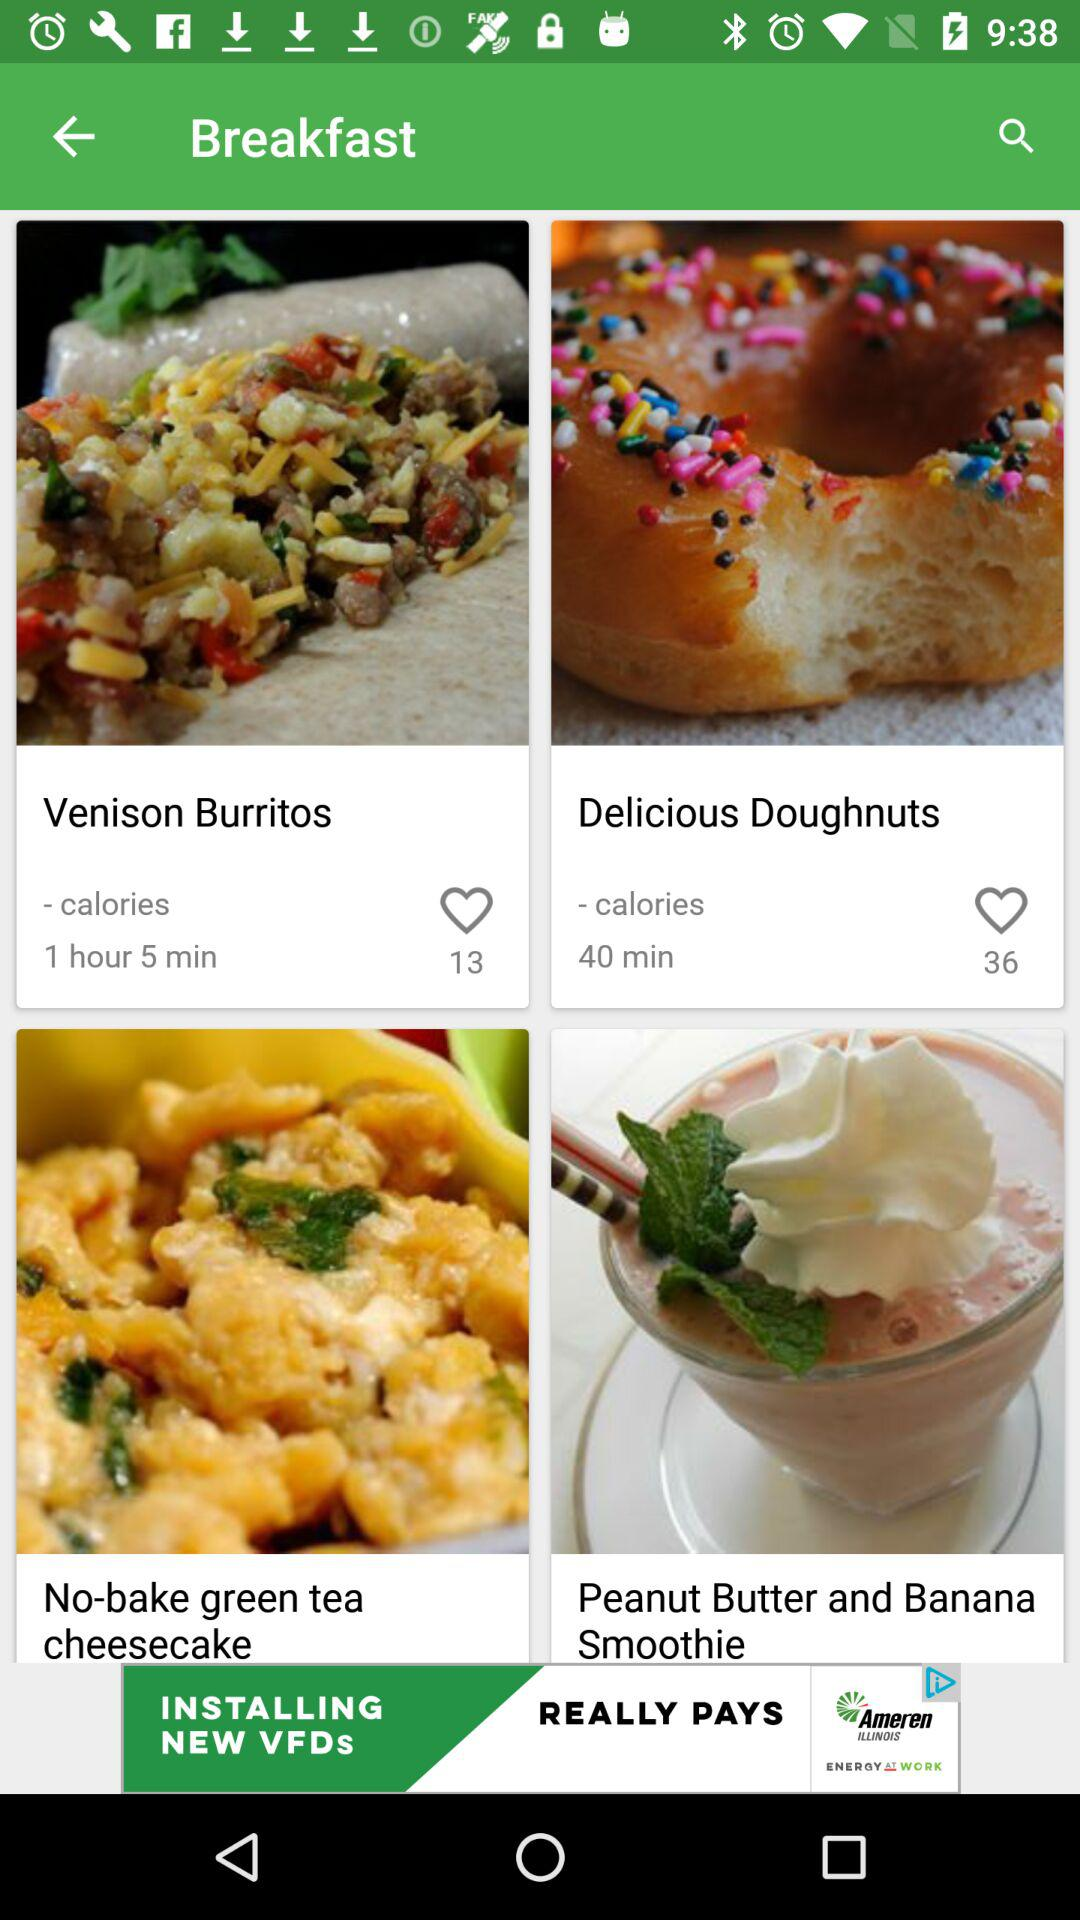How long will it take to prepare "Delicious Doughnuts"? It will take 40 minutes to prepare "Delicious Doughnuts". 